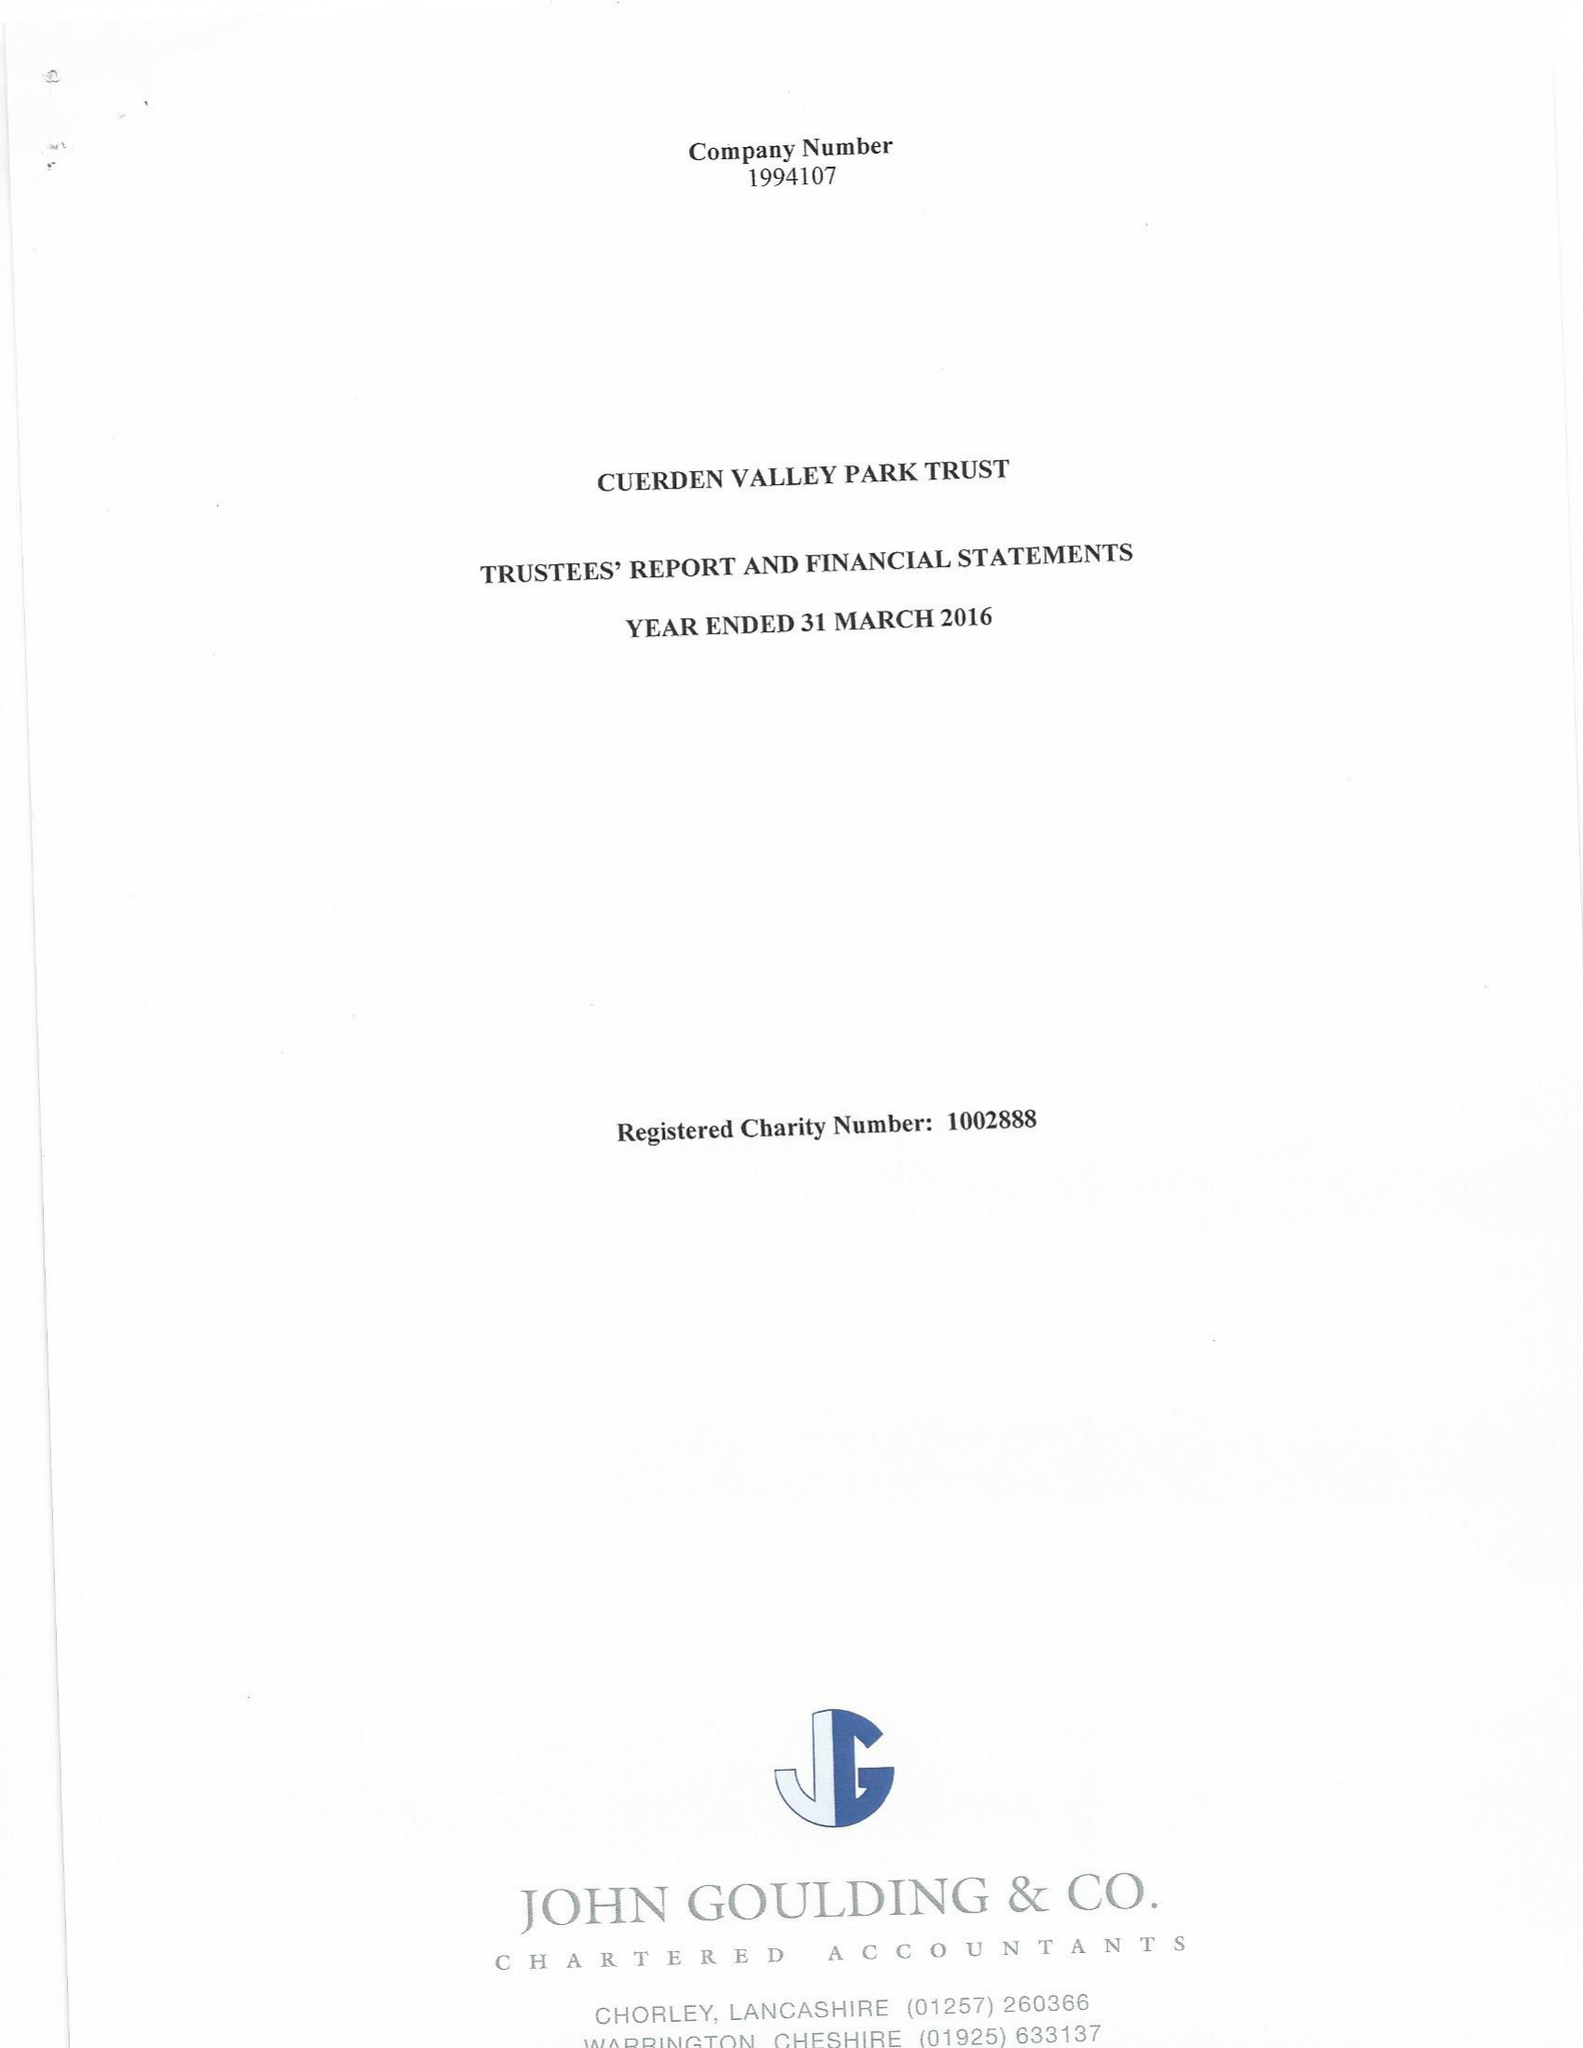What is the value for the charity_number?
Answer the question using a single word or phrase. 1002888 